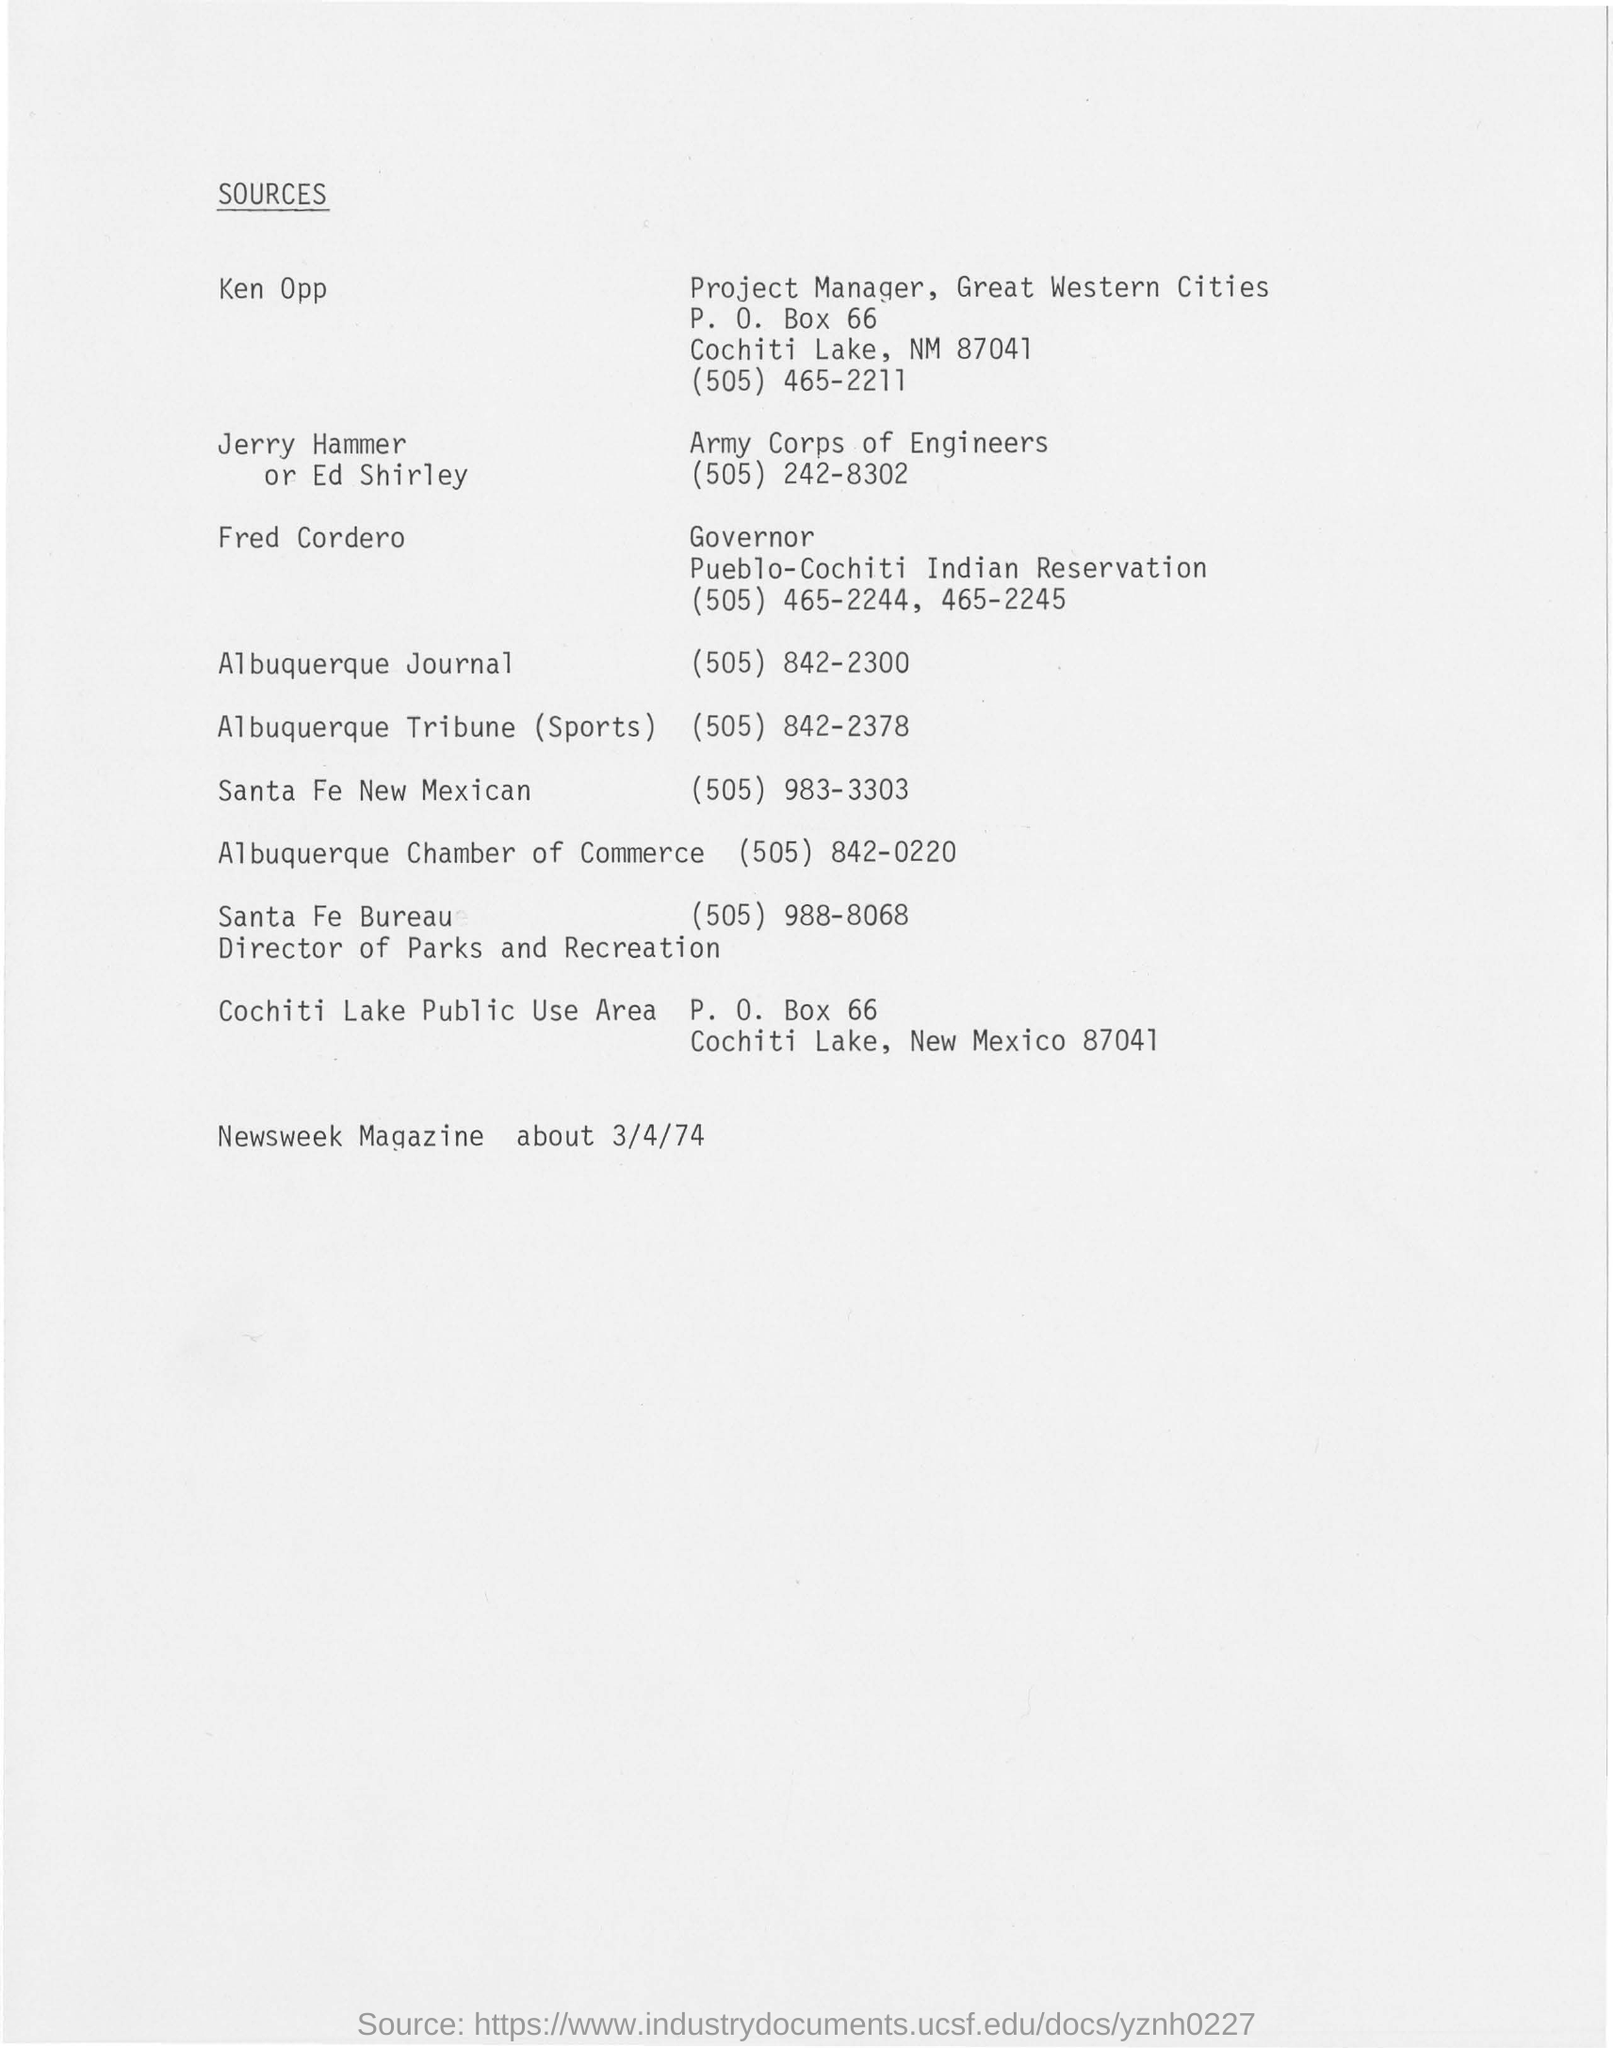Identify some key points in this picture. The contact number for Ken Opp is (505) 465-2211. The governor of the Pueblo-Cochiti Indian Reservation is Fred Cordero. The project manager of Great Western Cities is Ken Opp. 